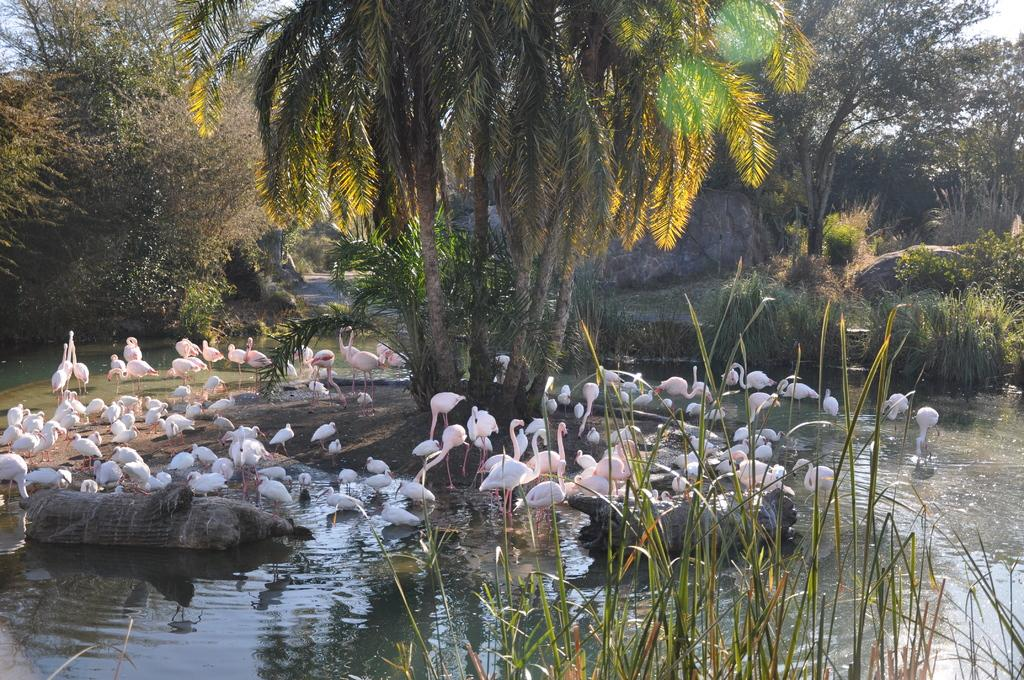What type of animals can be seen in the image? Birds can be seen in the image. What is the primary element in which the birds are situated? The birds are situated in water. What type of vegetation is present in the image? There are trees, plants, and grass in the image. What other natural elements can be seen in the image? There are rocks in the image. What type of haircut does the sand have in the image? There is no sand present in the image, and therefore no haircut can be observed. 